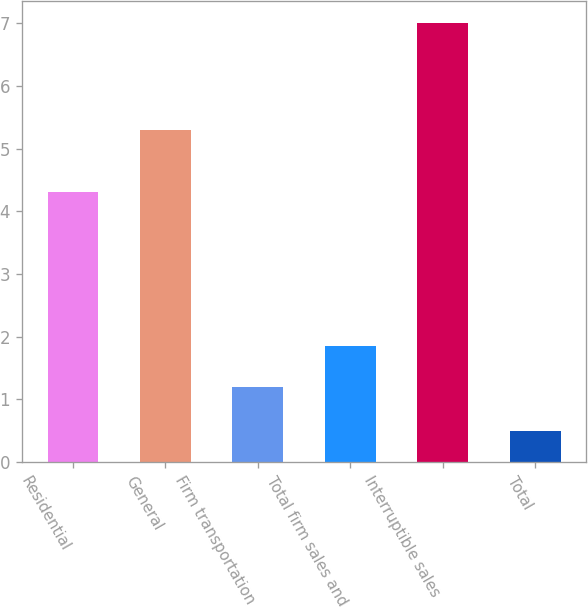<chart> <loc_0><loc_0><loc_500><loc_500><bar_chart><fcel>Residential<fcel>General<fcel>Firm transportation<fcel>Total firm sales and<fcel>Interruptible sales<fcel>Total<nl><fcel>4.3<fcel>5.3<fcel>1.2<fcel>1.85<fcel>7<fcel>0.5<nl></chart> 